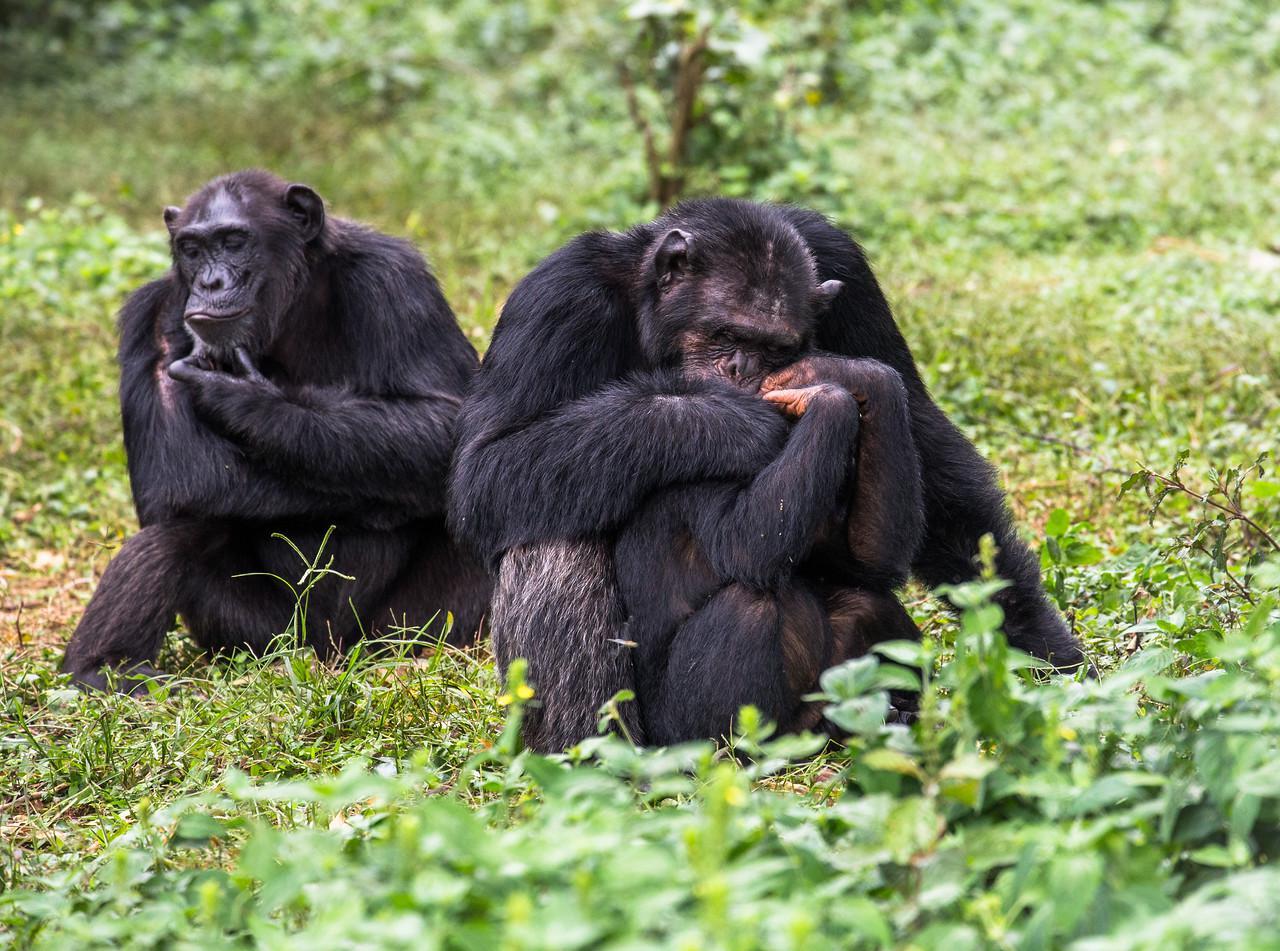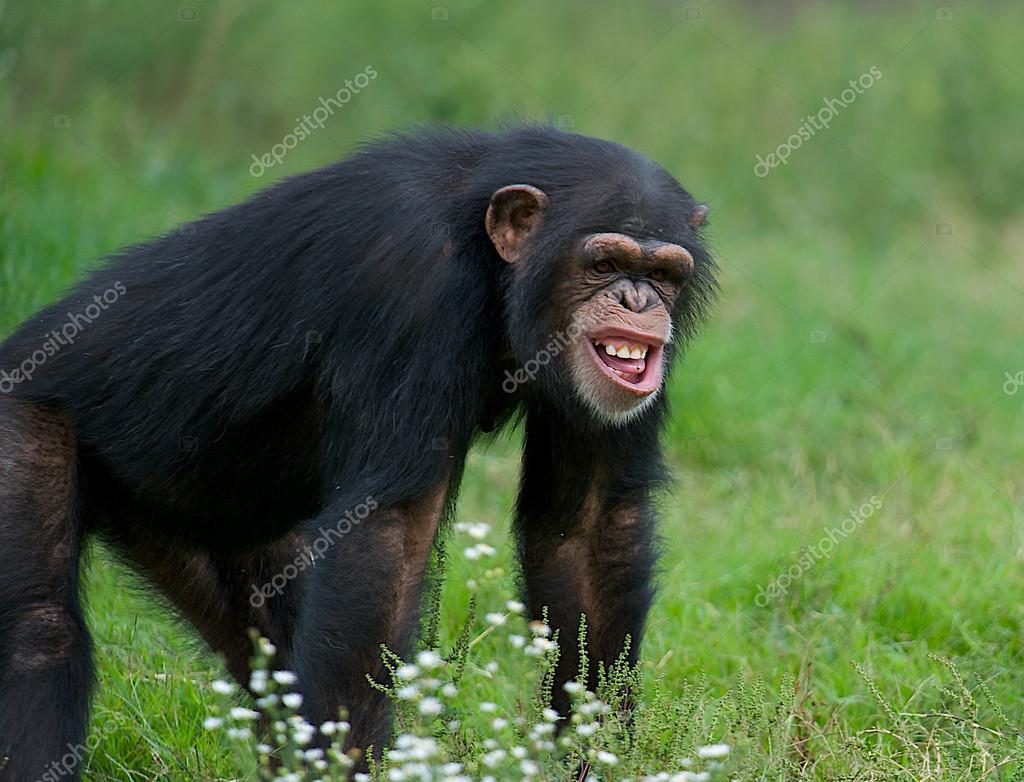The first image is the image on the left, the second image is the image on the right. For the images shown, is this caption "The left image shows a group of three apes, with a fourth ape in the background." true? Answer yes or no. No. 